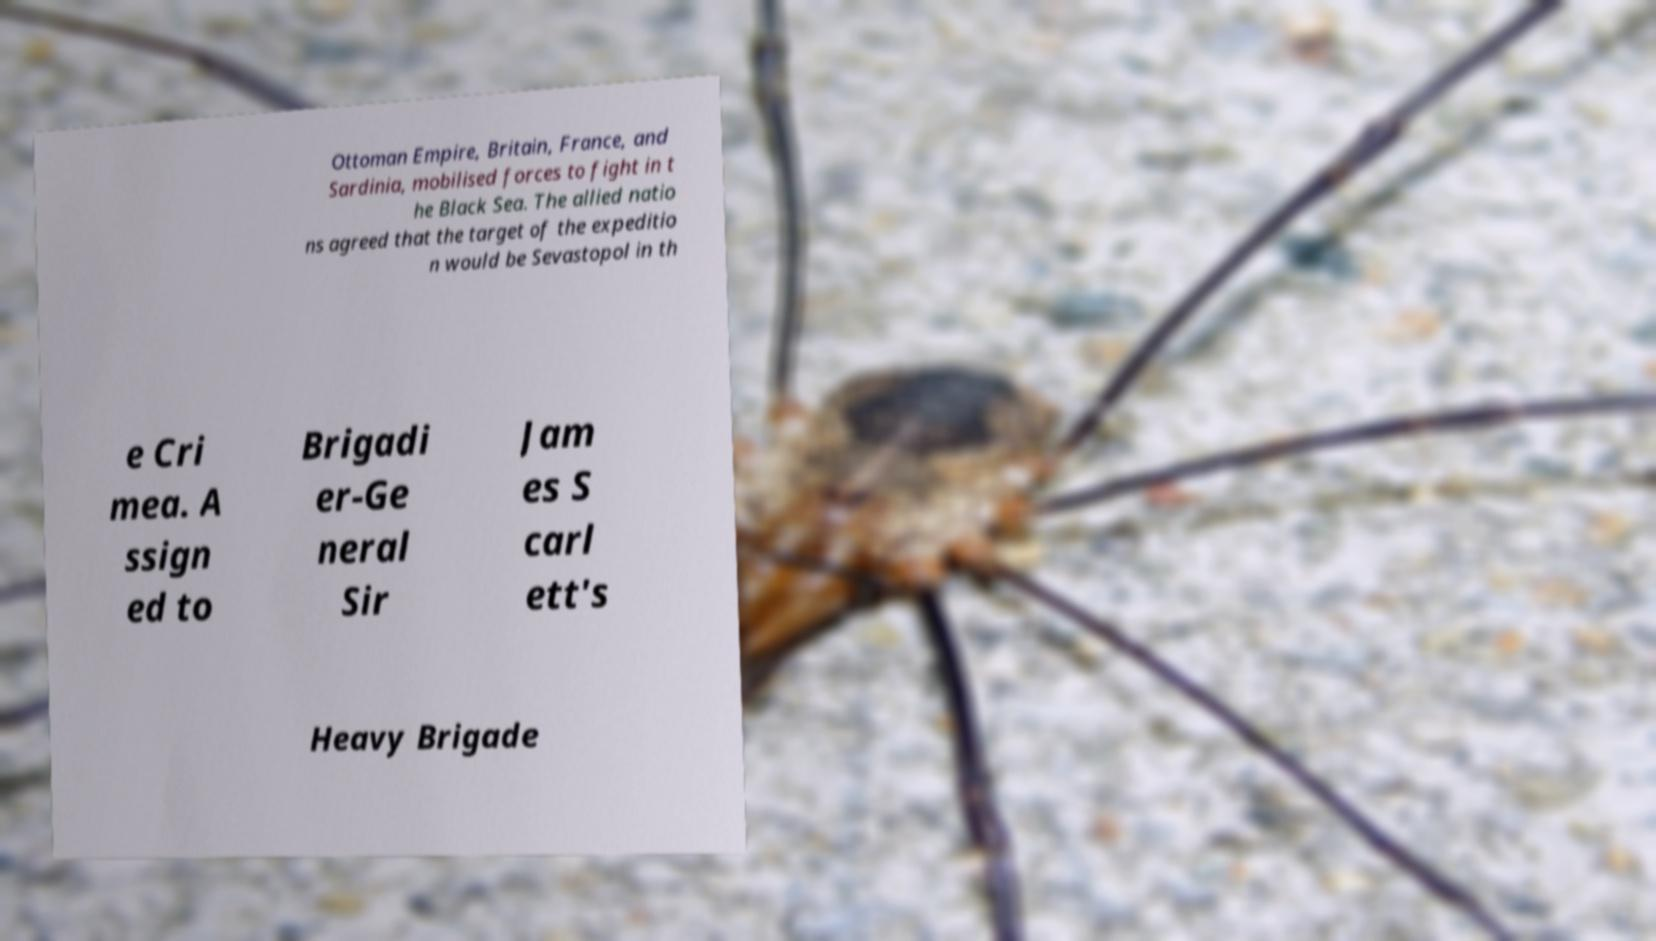Please read and relay the text visible in this image. What does it say? Ottoman Empire, Britain, France, and Sardinia, mobilised forces to fight in t he Black Sea. The allied natio ns agreed that the target of the expeditio n would be Sevastopol in th e Cri mea. A ssign ed to Brigadi er-Ge neral Sir Jam es S carl ett's Heavy Brigade 